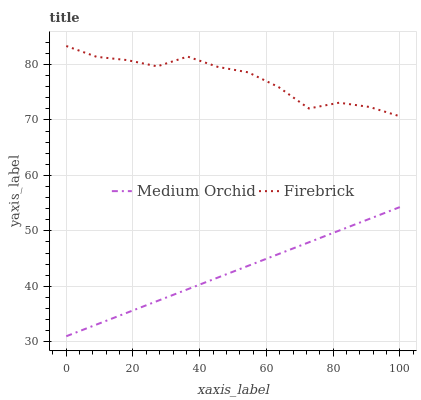Does Medium Orchid have the minimum area under the curve?
Answer yes or no. Yes. Does Firebrick have the maximum area under the curve?
Answer yes or no. Yes. Does Medium Orchid have the maximum area under the curve?
Answer yes or no. No. Is Medium Orchid the smoothest?
Answer yes or no. Yes. Is Firebrick the roughest?
Answer yes or no. Yes. Is Medium Orchid the roughest?
Answer yes or no. No. Does Medium Orchid have the lowest value?
Answer yes or no. Yes. Does Firebrick have the highest value?
Answer yes or no. Yes. Does Medium Orchid have the highest value?
Answer yes or no. No. Is Medium Orchid less than Firebrick?
Answer yes or no. Yes. Is Firebrick greater than Medium Orchid?
Answer yes or no. Yes. Does Medium Orchid intersect Firebrick?
Answer yes or no. No. 